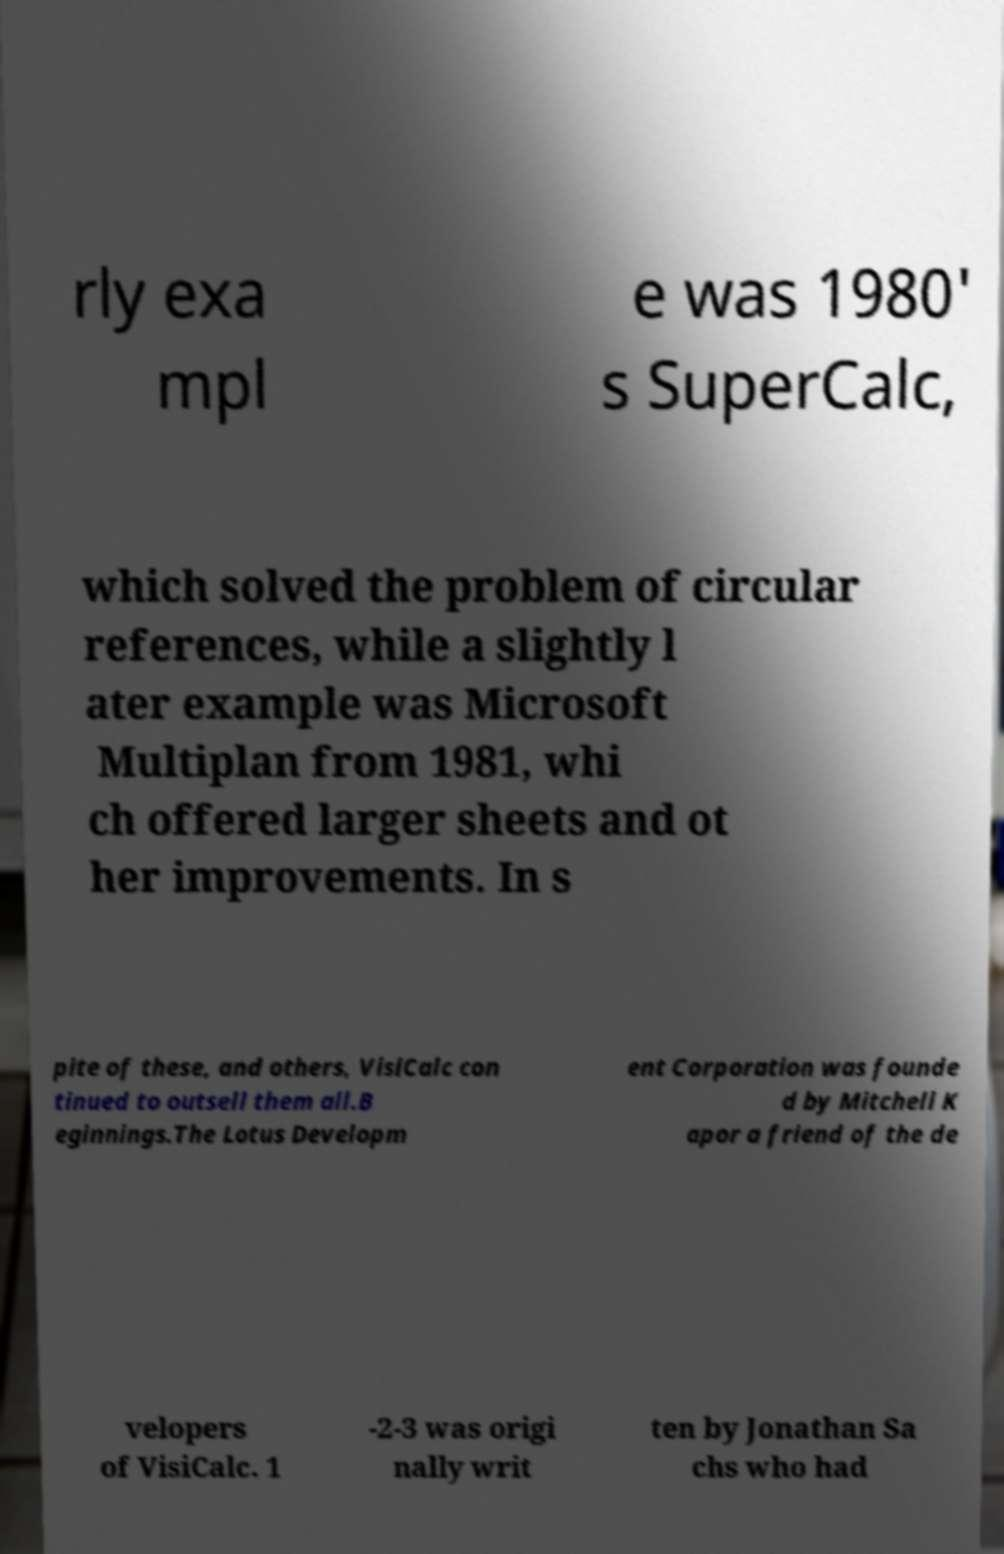What messages or text are displayed in this image? I need them in a readable, typed format. rly exa mpl e was 1980' s SuperCalc, which solved the problem of circular references, while a slightly l ater example was Microsoft Multiplan from 1981, whi ch offered larger sheets and ot her improvements. In s pite of these, and others, VisiCalc con tinued to outsell them all.B eginnings.The Lotus Developm ent Corporation was founde d by Mitchell K apor a friend of the de velopers of VisiCalc. 1 -2-3 was origi nally writ ten by Jonathan Sa chs who had 